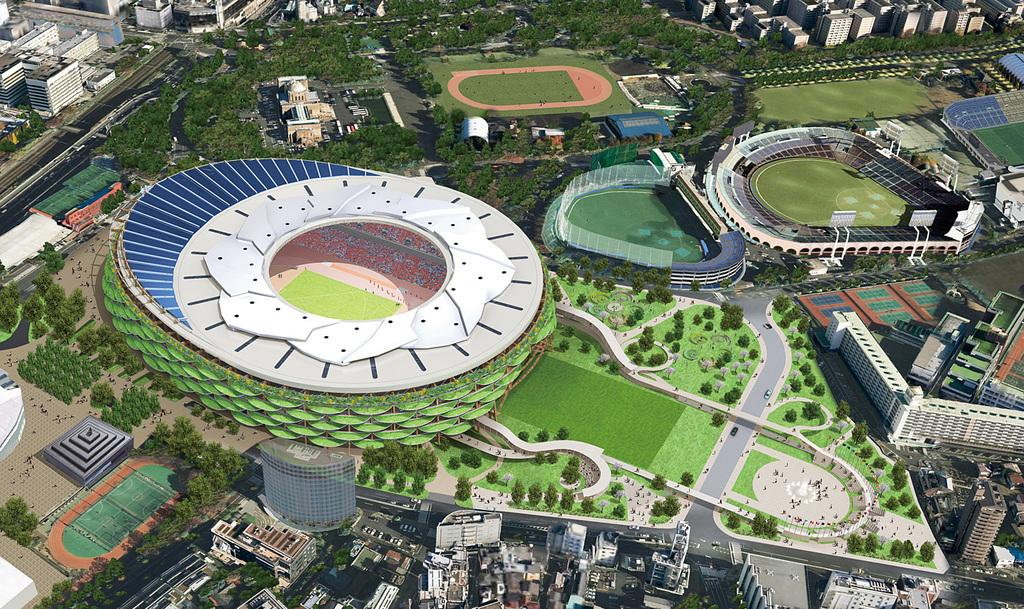What type of view is shown in the image? The image is an aerial view of a city. What specific structures can be seen in the city? There are stadiums and buildings visible in the image. What type of natural elements are present in the image? There are gardens, plants, and trees visible in the image. What is the transportation infrastructure like in the image? There is a road visible in the image, and vehicles are present on the road. What type of print can be seen on the plough in the image? There is no plough present in the image; it is an aerial view of a city with various structures and natural elements. What direction is the zephyr blowing in the image? There is no mention of a zephyr or any wind in the image; it is a still image of a city. 